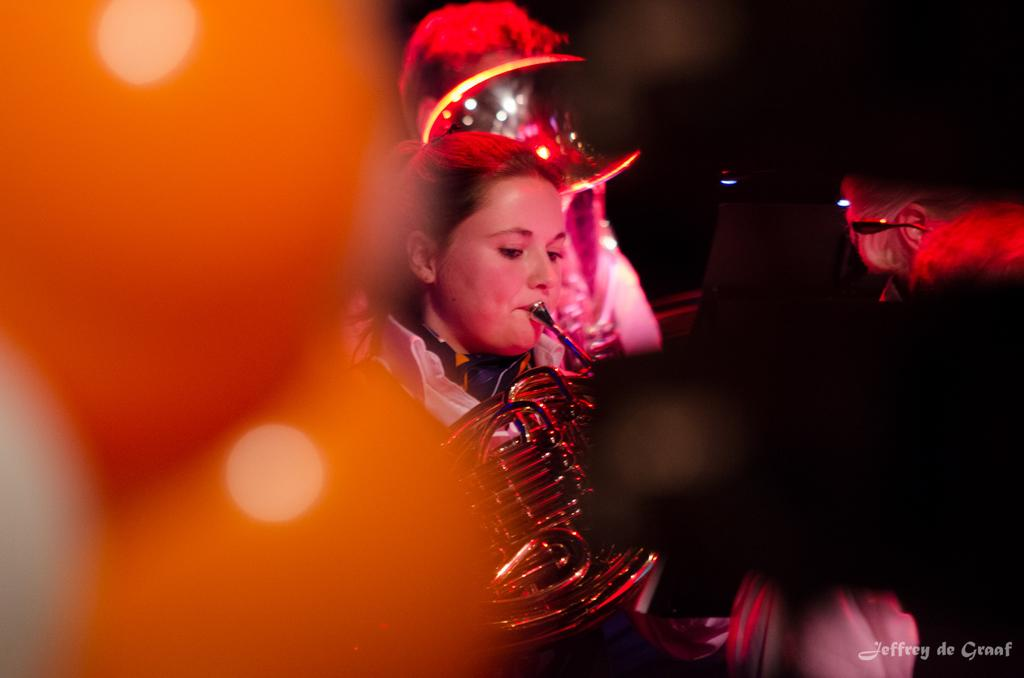What is the woman in the image doing? The woman is playing a musical instrument in the image. Can you describe the people around the woman? There is a person behind the woman and another person on the right side of the image. What can be said about the background of the image? The background of the image is blurry. What is the size of the arch in the image? There is no arch present in the image. How many songs can be heard being played by the woman in the image? The image is a still image, so it does not capture any sound, including songs being played by the woman. 